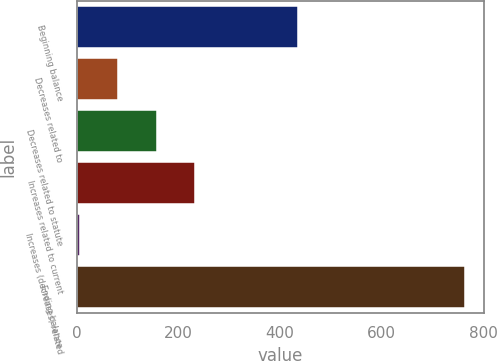<chart> <loc_0><loc_0><loc_500><loc_500><bar_chart><fcel>Beginning balance<fcel>Decreases related to<fcel>Decreases related to statute<fcel>Increases related to current<fcel>Increases (decreases) related<fcel>Ending balance<nl><fcel>436<fcel>81.38<fcel>157.16<fcel>232.94<fcel>5.6<fcel>763.4<nl></chart> 